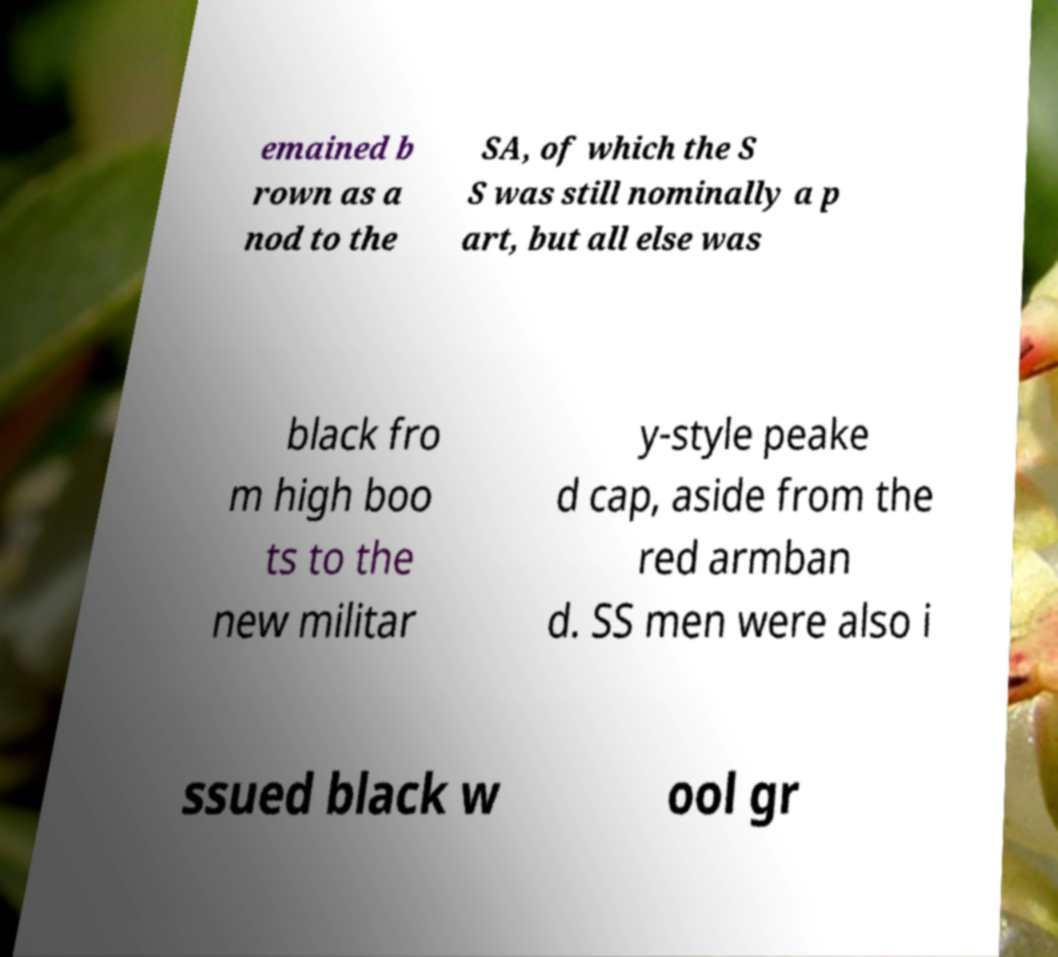I need the written content from this picture converted into text. Can you do that? emained b rown as a nod to the SA, of which the S S was still nominally a p art, but all else was black fro m high boo ts to the new militar y-style peake d cap, aside from the red armban d. SS men were also i ssued black w ool gr 